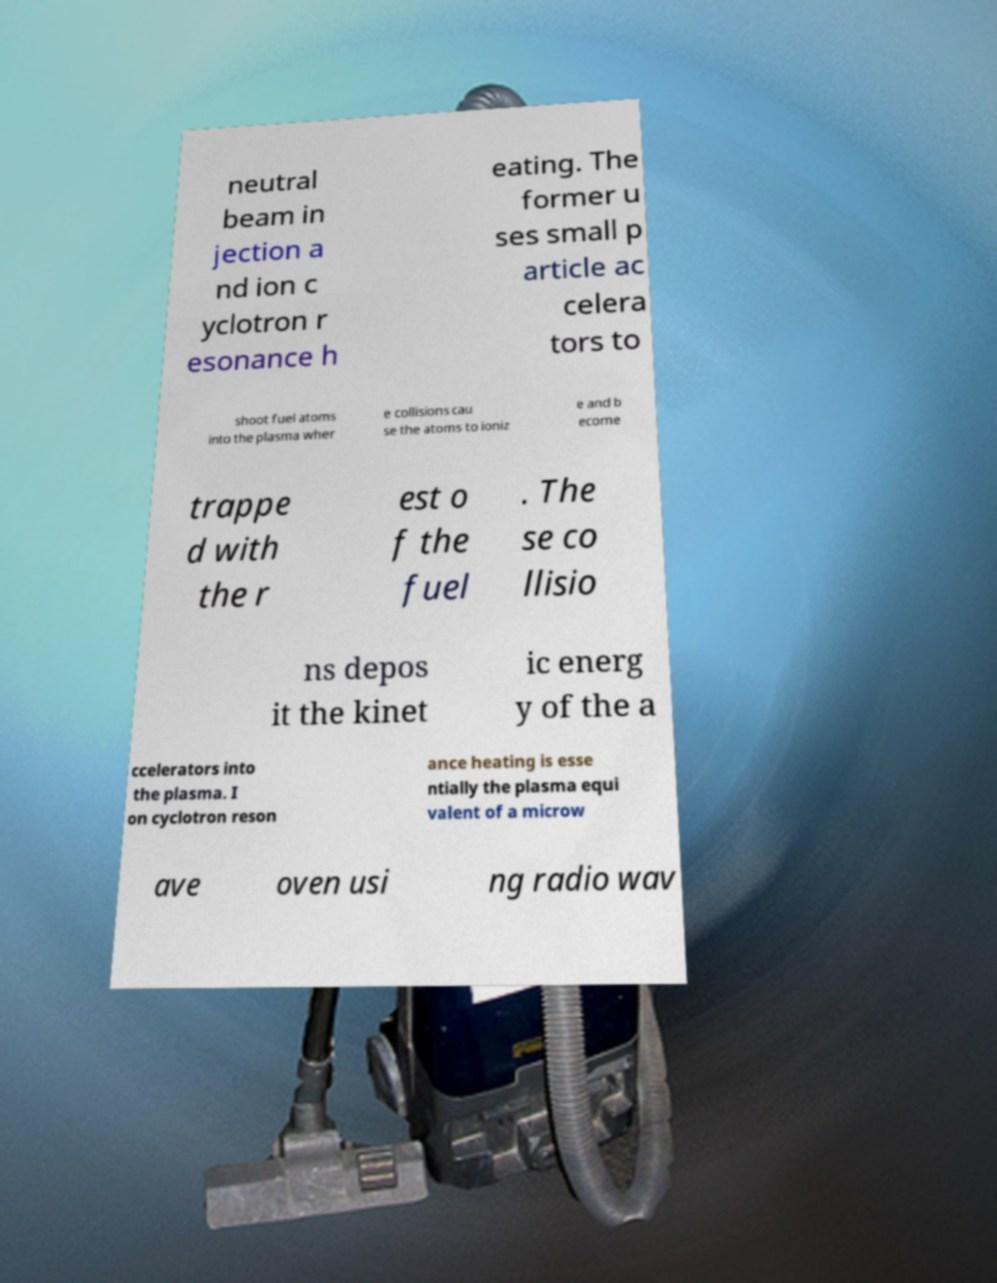Please identify and transcribe the text found in this image. neutral beam in jection a nd ion c yclotron r esonance h eating. The former u ses small p article ac celera tors to shoot fuel atoms into the plasma wher e collisions cau se the atoms to ioniz e and b ecome trappe d with the r est o f the fuel . The se co llisio ns depos it the kinet ic energ y of the a ccelerators into the plasma. I on cyclotron reson ance heating is esse ntially the plasma equi valent of a microw ave oven usi ng radio wav 